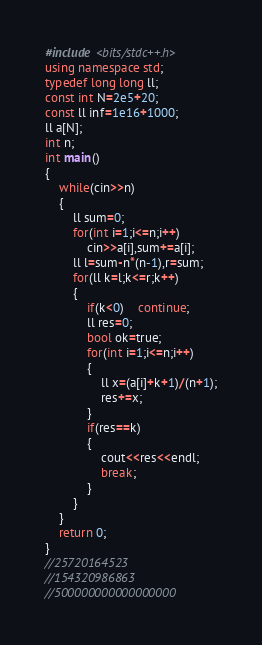Convert code to text. <code><loc_0><loc_0><loc_500><loc_500><_C++_>#include <bits/stdc++.h>
using namespace std;
typedef long long ll;
const int N=2e5+20;
const ll inf=1e16+1000;
ll a[N];
int n;
int main()
{
	while(cin>>n)
	{
		ll sum=0;
		for(int i=1;i<=n;i++)
			cin>>a[i],sum+=a[i];
		ll l=sum-n*(n-1),r=sum;
		for(ll k=l;k<=r;k++)
		{
			if(k<0)	continue;
			ll res=0;
			bool ok=true;
			for(int i=1;i<=n;i++)
			{
				ll x=(a[i]+k+1)/(n+1);
				res+=x;
			}
			if(res==k)
			{
				cout<<res<<endl;
				break;
			}
		}
	}
	return 0;
}
//25720164523
//154320986863
//500000000000000000</code> 